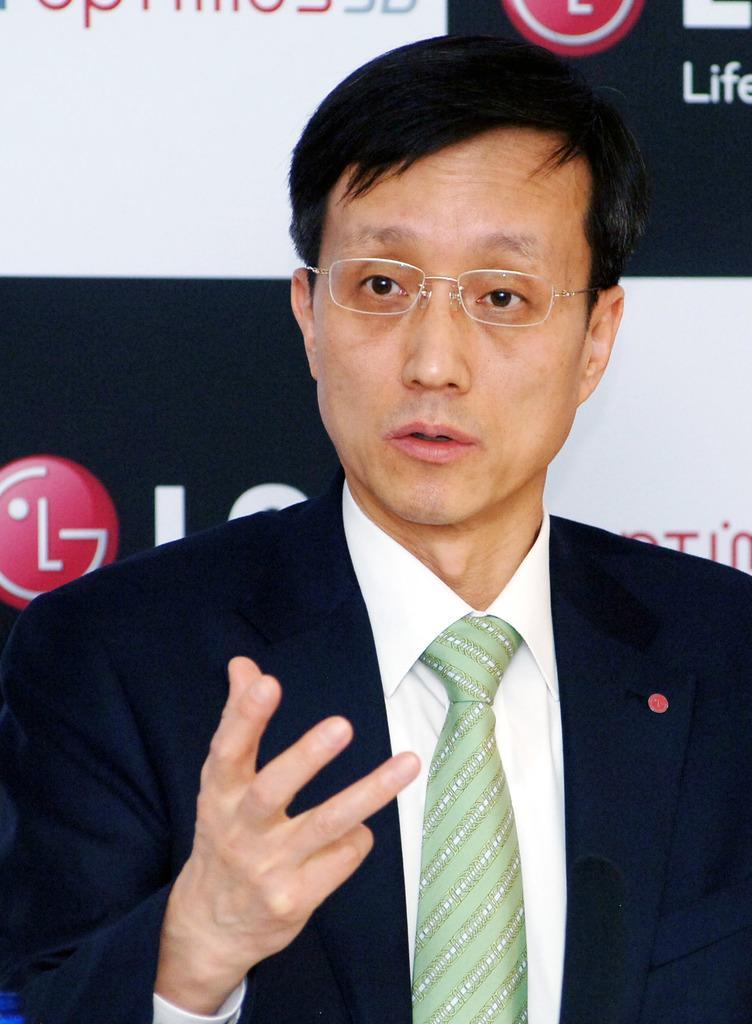Describe this image in one or two sentences. In this picture I can see a person wearing spectacles and talking, behind there is a board with some text and logo. 